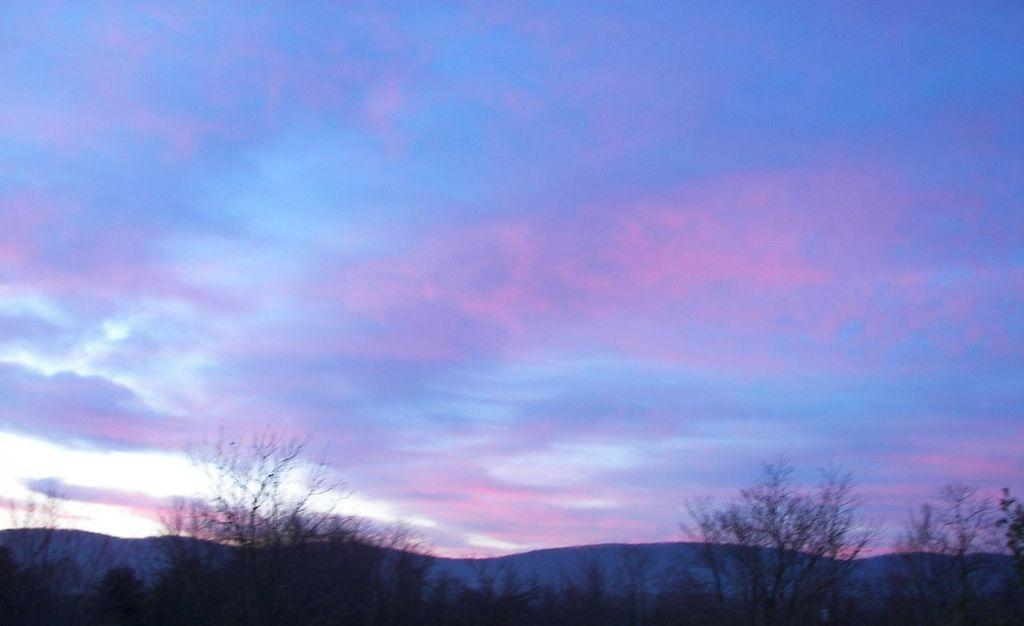What type of vegetation can be seen in the image? There are trees in the image. What can be seen in the sky in the image? There are clouds in the image. What part of the natural environment is visible in the image? The sky is visible in the image. What type of leather is used to make the crib in the image? There is no crib present in the image, so it is not possible to determine what type of leather might be used. 